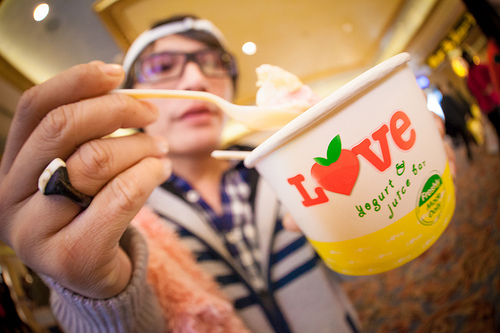<image>
Can you confirm if the spoon is in the yogurt? Yes. The spoon is contained within or inside the yogurt, showing a containment relationship. 